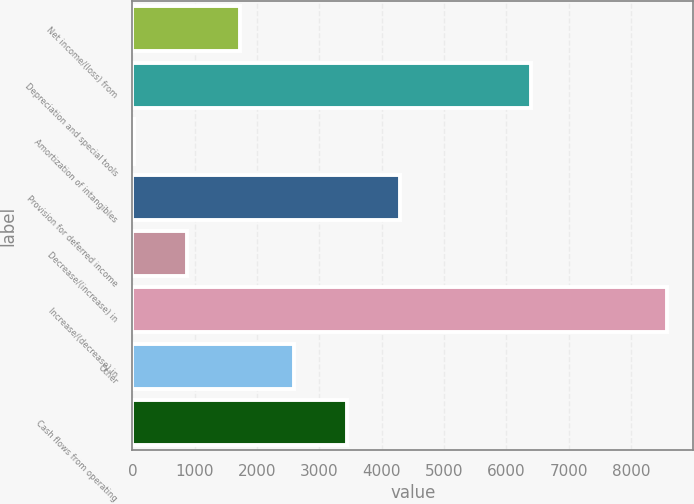Convert chart to OTSL. <chart><loc_0><loc_0><loc_500><loc_500><bar_chart><fcel>Net income/(loss) from<fcel>Depreciation and special tools<fcel>Amortization of intangibles<fcel>Provision for deferred income<fcel>Decrease/(increase) in<fcel>Increase/(decrease) in<fcel>Other<fcel>Cash flows from operating<nl><fcel>1735<fcel>6398<fcel>26<fcel>4298.5<fcel>880.5<fcel>8571<fcel>2589.5<fcel>3444<nl></chart> 